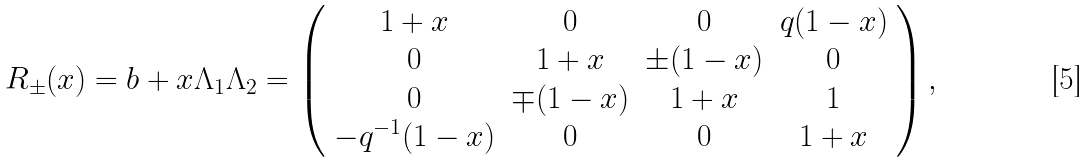Convert formula to latex. <formula><loc_0><loc_0><loc_500><loc_500>R _ { \pm } ( x ) = b + x \Lambda _ { 1 } \Lambda _ { 2 } = \left ( \begin{array} { c c c c } 1 + x & 0 & 0 & q ( 1 - x ) \\ 0 & 1 + x & \pm ( 1 - x ) & 0 \\ 0 & \mp ( 1 - x ) & 1 + x & 1 \\ - q ^ { - 1 } ( 1 - x ) & 0 & 0 & 1 + x \end{array} \right ) ,</formula> 